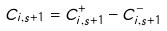Convert formula to latex. <formula><loc_0><loc_0><loc_500><loc_500>C _ { i , s + 1 } = C _ { i , s + 1 } ^ { + } - C _ { i , s + 1 } ^ { - }</formula> 